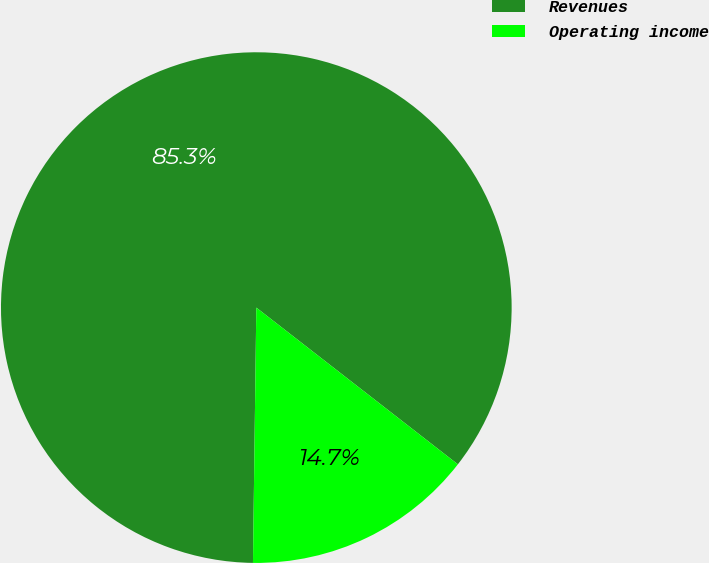Convert chart. <chart><loc_0><loc_0><loc_500><loc_500><pie_chart><fcel>Revenues<fcel>Operating income<nl><fcel>85.31%<fcel>14.69%<nl></chart> 